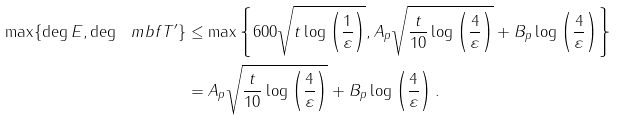Convert formula to latex. <formula><loc_0><loc_0><loc_500><loc_500>\max \{ \deg E , \deg \ m b f { T } ^ { \prime } \} & \leq \max \left \{ 6 0 0 \sqrt { t \log \left ( \frac { 1 } { \varepsilon } \right ) } , A _ { p } \sqrt { \frac { t } { 1 0 } \log \left ( \frac { 4 } { \varepsilon } \right ) } + B _ { p } \log \left ( \frac { 4 } { \varepsilon } \right ) \right \} \\ & = A _ { p } \sqrt { \frac { t } { 1 0 } \log \left ( \frac { 4 } { \varepsilon } \right ) } + B _ { p } \log \left ( \frac { 4 } { \varepsilon } \right ) .</formula> 